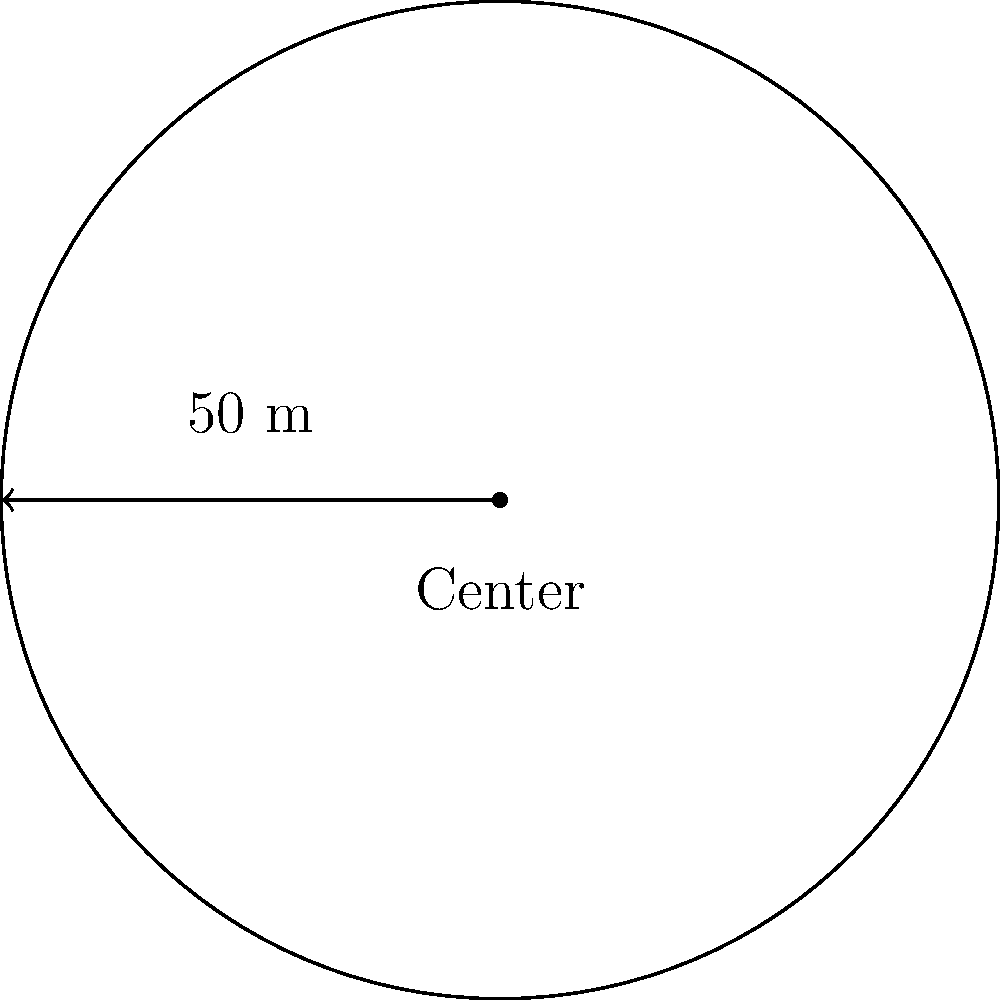FC Barcelona's training ground includes a circular field with a radius of 50 meters. If Lionel Messi wants to run around the entire perimeter of this field for his warm-up, what distance will he cover in one lap? To find the perimeter of the circular training ground, we need to calculate its circumference. The formula for the circumference of a circle is:

$$C = 2\pi r$$

Where:
$C$ = circumference
$\pi$ = pi (approximately 3.14159)
$r$ = radius

Given:
Radius of the field = 50 meters

Let's calculate:

$$\begin{align}
C &= 2\pi r \\
&= 2 \times \pi \times 50 \\
&= 100\pi \\
&\approx 100 \times 3.14159 \\
&\approx 314.159 \text{ meters}
\end{align}$$

Therefore, Messi will run approximately 314.159 meters in one lap around the circular training ground.
Answer: $314.159$ meters 